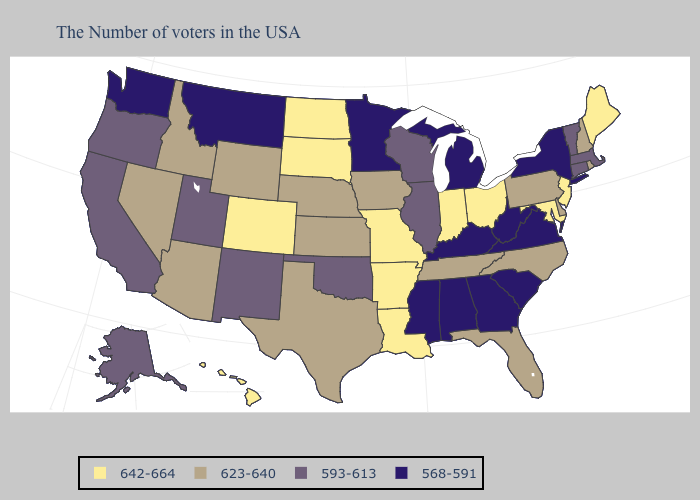Name the states that have a value in the range 623-640?
Quick response, please. Rhode Island, New Hampshire, Delaware, Pennsylvania, North Carolina, Florida, Tennessee, Iowa, Kansas, Nebraska, Texas, Wyoming, Arizona, Idaho, Nevada. Name the states that have a value in the range 593-613?
Quick response, please. Massachusetts, Vermont, Connecticut, Wisconsin, Illinois, Oklahoma, New Mexico, Utah, California, Oregon, Alaska. Does the map have missing data?
Answer briefly. No. Name the states that have a value in the range 623-640?
Quick response, please. Rhode Island, New Hampshire, Delaware, Pennsylvania, North Carolina, Florida, Tennessee, Iowa, Kansas, Nebraska, Texas, Wyoming, Arizona, Idaho, Nevada. Among the states that border Illinois , which have the lowest value?
Concise answer only. Kentucky. What is the lowest value in states that border Mississippi?
Concise answer only. 568-591. Name the states that have a value in the range 568-591?
Short answer required. New York, Virginia, South Carolina, West Virginia, Georgia, Michigan, Kentucky, Alabama, Mississippi, Minnesota, Montana, Washington. Among the states that border Oregon , which have the highest value?
Quick response, please. Idaho, Nevada. Does the first symbol in the legend represent the smallest category?
Give a very brief answer. No. What is the value of Iowa?
Quick response, please. 623-640. Name the states that have a value in the range 593-613?
Quick response, please. Massachusetts, Vermont, Connecticut, Wisconsin, Illinois, Oklahoma, New Mexico, Utah, California, Oregon, Alaska. What is the value of Utah?
Write a very short answer. 593-613. What is the lowest value in the USA?
Give a very brief answer. 568-591. Which states have the highest value in the USA?
Write a very short answer. Maine, New Jersey, Maryland, Ohio, Indiana, Louisiana, Missouri, Arkansas, South Dakota, North Dakota, Colorado, Hawaii. 